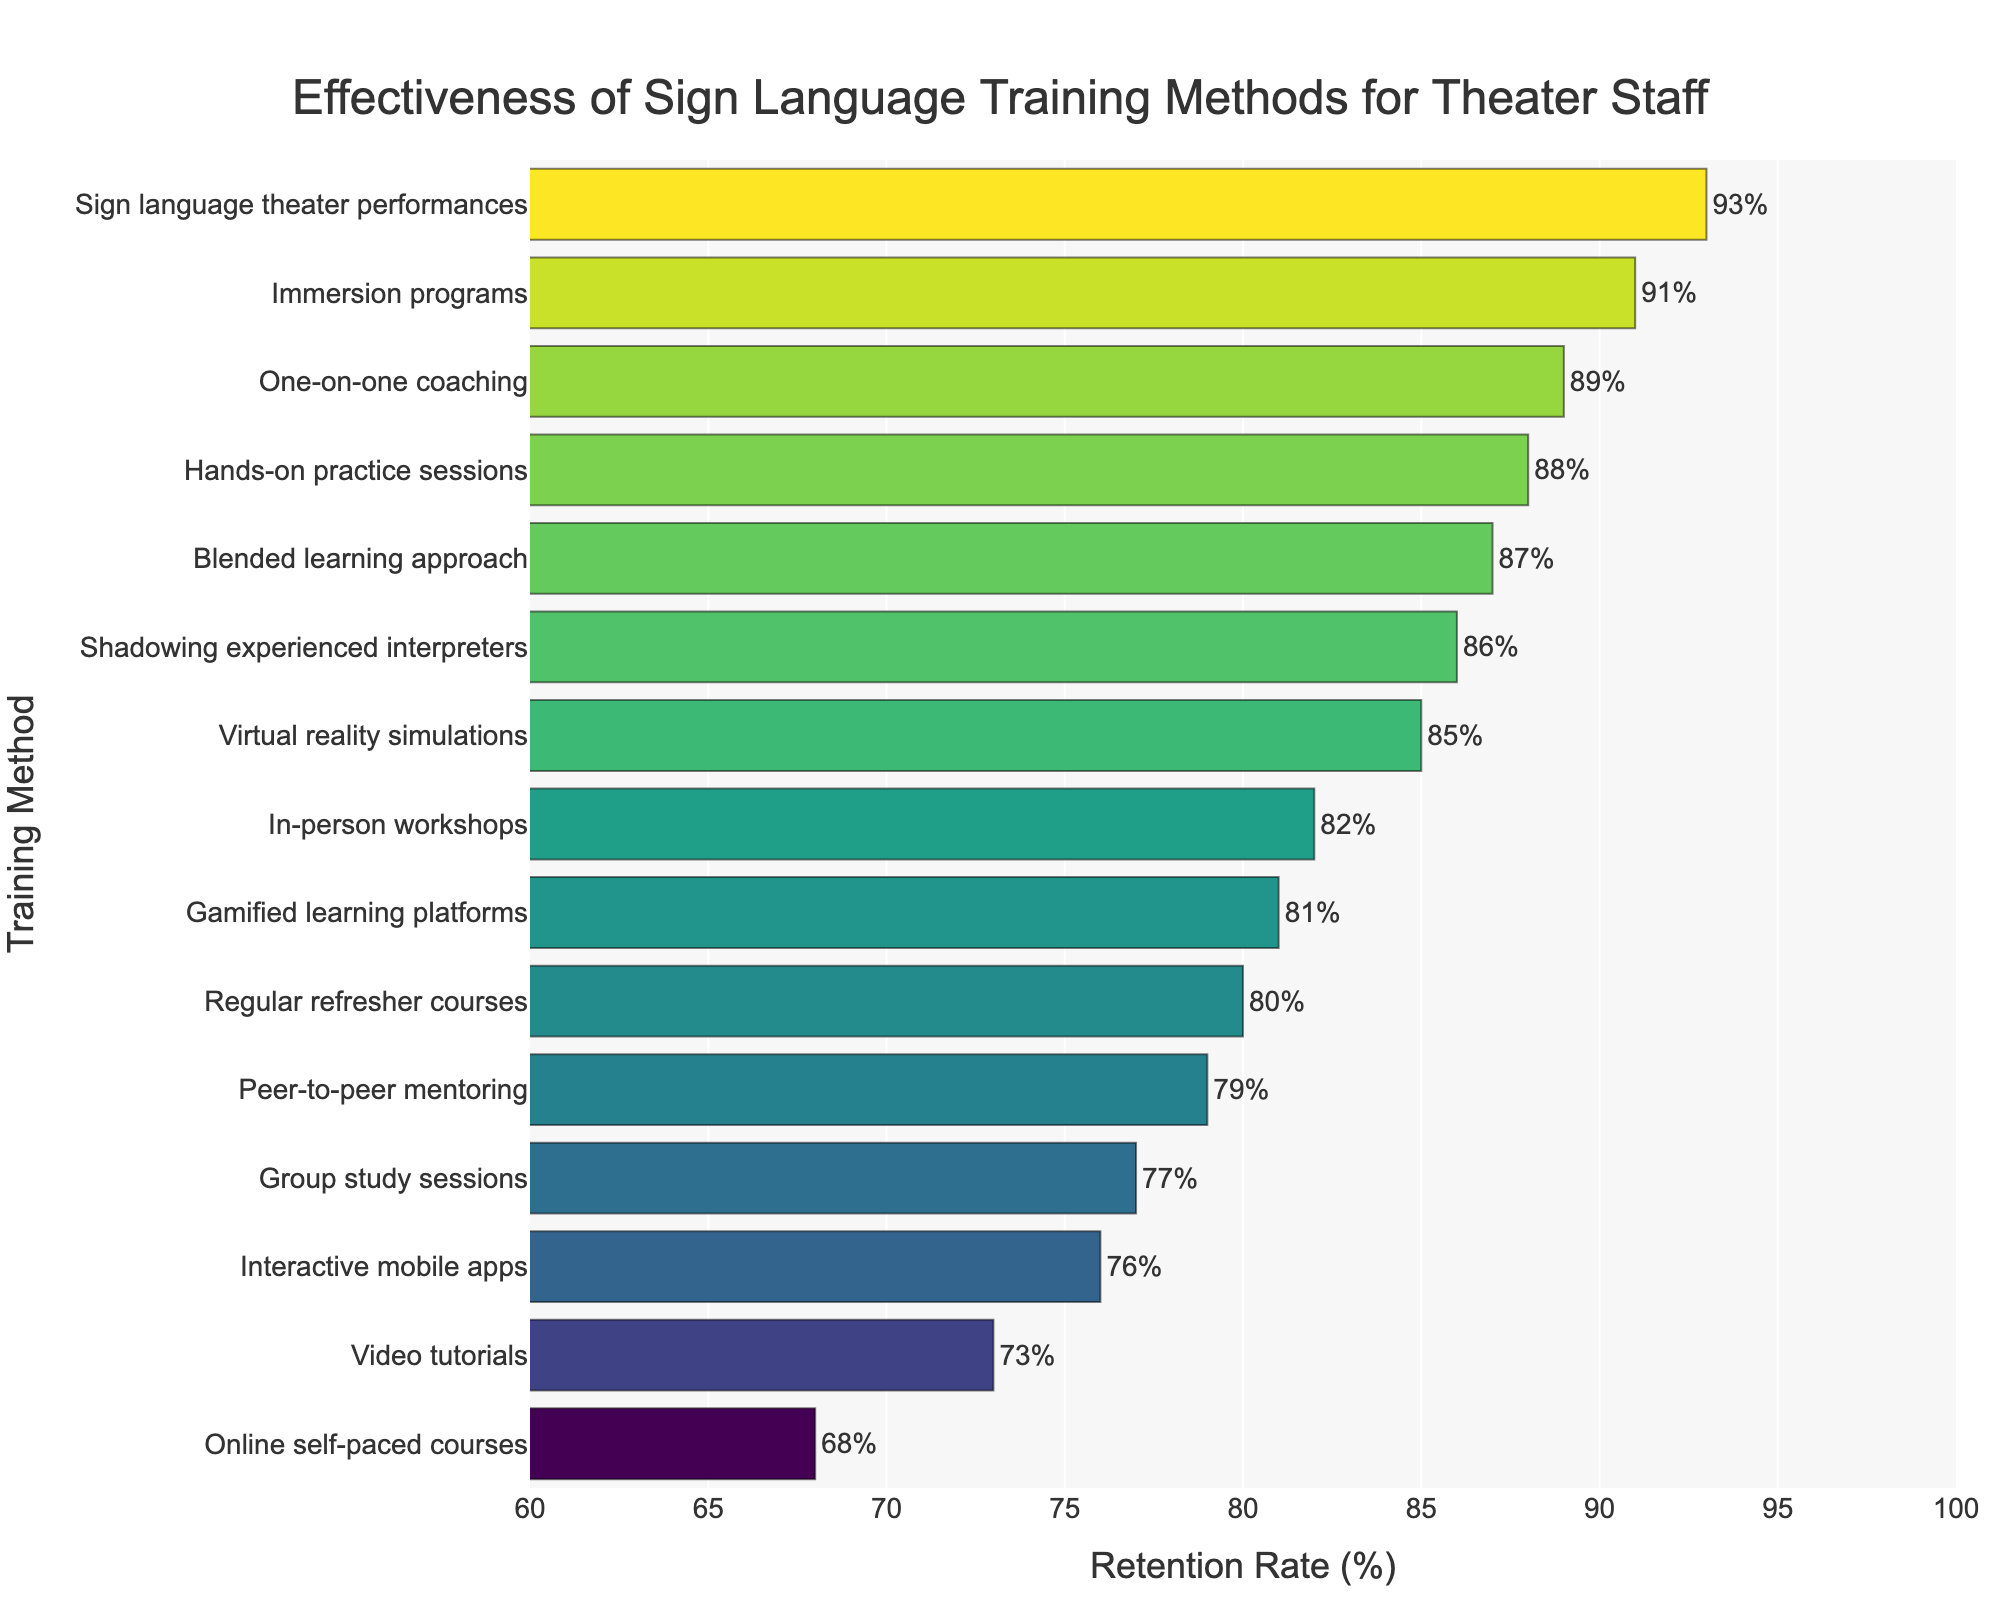Which training method has the highest retention rate? The training method with the highest retention rate is represented by the longest bar in the chart. By examining the chart, we see that "Sign language theater performances" has the longest bar, indicating the highest retention rate.
Answer: Sign language theater performances Which training method has the lowest retention rate? The training method with the lowest retention rate can be identified by the shortest bar in the chart. "Online self-paced courses" has the shortest bar, representing the lowest retention rate of 68%.
Answer: Online self-paced courses How many training methods have a retention rate greater than 80%? To determine this, count the number of bars that extend beyond the 80% mark on the x-axis. The methods that meet this criterion are "In-person workshops," "Immersion programs," "Hands-on practice sessions," "Blended learning approach," "Sign language theater performances," "Shadowing experienced interpreters," and "One-on-one coaching." There are 7 methods in total.
Answer: 7 What is the difference in retention rates between the most effective and least effective training methods? The most effective method is "Sign language theater performances" with a 93% retention rate, and the least effective method is "Online self-paced courses" with a 68% retention rate. The difference is 93% - 68% = 25%.
Answer: 25% Which training method is more effective, "Virtual reality simulations" or "Interactive mobile apps"? By how much? Compare the retention rates of the two methods from the chart. "Virtual reality simulations" has a retention rate of 85%, and "Interactive mobile apps" has a retention rate of 76%. The difference is 85% - 76% = 9%.
Answer: Virtual reality simulations by 9% Are there more methods with retention rates above 85% or below 75%? First, count the methods with retention rates above 85%: "Immersion programs," "Hands-on practice sessions," "Blended learning approach," "Sign language theater performances," "Shadowing experienced interpreters," "One-on-one coaching" (6 methods). Next, count those below 75%: "Online self-paced courses," "Video tutorials" (2 methods). There are more methods above 85%.
Answer: Above 85% What's the average retention rate of the top 3 training methods? The top 3 training methods based on retention rates are "Sign language theater performances" (93%), "Immersion programs" (91%), and "One-on-one coaching" (89%). The average is (93 + 91 + 89) / 3 = 91%.
Answer: 91% How do "Gamified learning platforms" and "Peer-to-peer mentoring" compare in terms of retention rate? "Gamified learning platforms" have a retention rate of 81%, while "Peer-to-peer mentoring" has a retention rate of 79%. "Gamified learning platforms" have a slightly higher retention rate by 2%.
Answer: Gamified learning platforms have a 2% higher retention rate What is the median retention rate of all the training methods? To find the median, first list all the retention rates in ascending order: 68, 73, 76, 77, 79, 80, 81, 82, 85, 86, 87, 88, 89, 91, 93. With 15 data points, the median is the 8th value, which is 81%.
Answer: 81% Do "Regular refresher courses" have a higher retention rate than "Video tutorials"? By how much? "Regular refresher courses" have a retention rate of 80%, while "Video tutorials" have a retention rate of 73%. The difference is 80% - 73% = 7%.
Answer: Regular refresher courses by 7% 